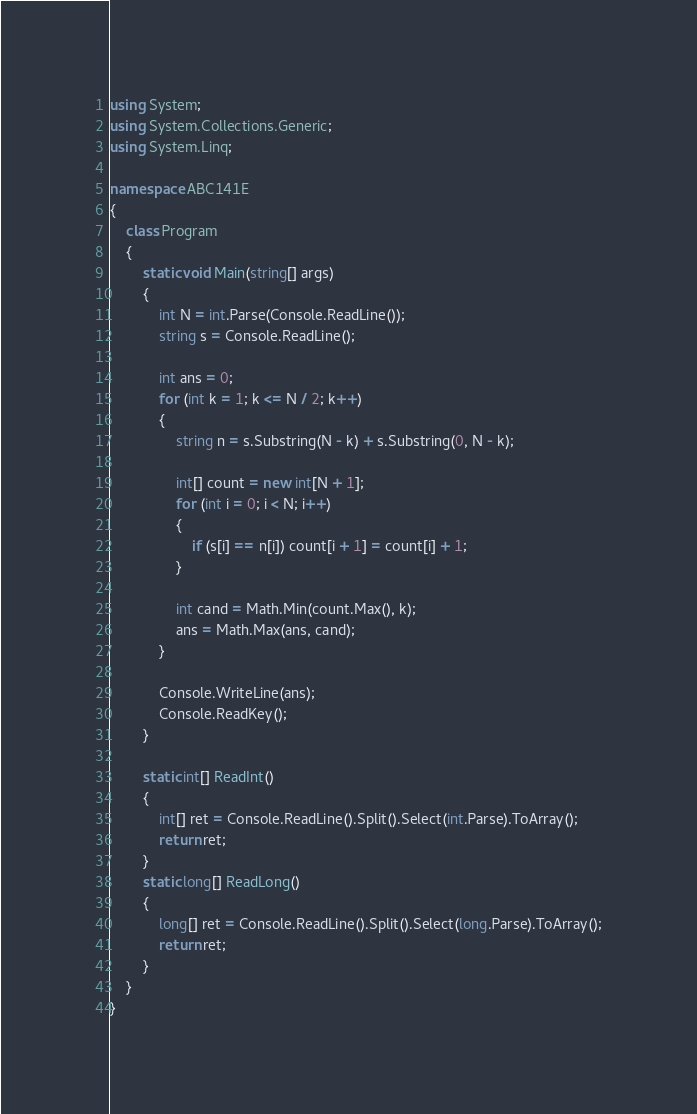Convert code to text. <code><loc_0><loc_0><loc_500><loc_500><_C#_>using System;
using System.Collections.Generic;
using System.Linq;

namespace ABC141E
{
    class Program
    {
        static void Main(string[] args)
        {
            int N = int.Parse(Console.ReadLine());
            string s = Console.ReadLine();

            int ans = 0;
            for (int k = 1; k <= N / 2; k++)
            {
                string n = s.Substring(N - k) + s.Substring(0, N - k);

                int[] count = new int[N + 1];
                for (int i = 0; i < N; i++)
                {
                    if (s[i] == n[i]) count[i + 1] = count[i] + 1;
                }

                int cand = Math.Min(count.Max(), k);
                ans = Math.Max(ans, cand);
            }

            Console.WriteLine(ans);
            Console.ReadKey();
        }

        static int[] ReadInt()
        {
            int[] ret = Console.ReadLine().Split().Select(int.Parse).ToArray();
            return ret;
        }
        static long[] ReadLong()
        {
            long[] ret = Console.ReadLine().Split().Select(long.Parse).ToArray();
            return ret;
        }
    }
}
</code> 